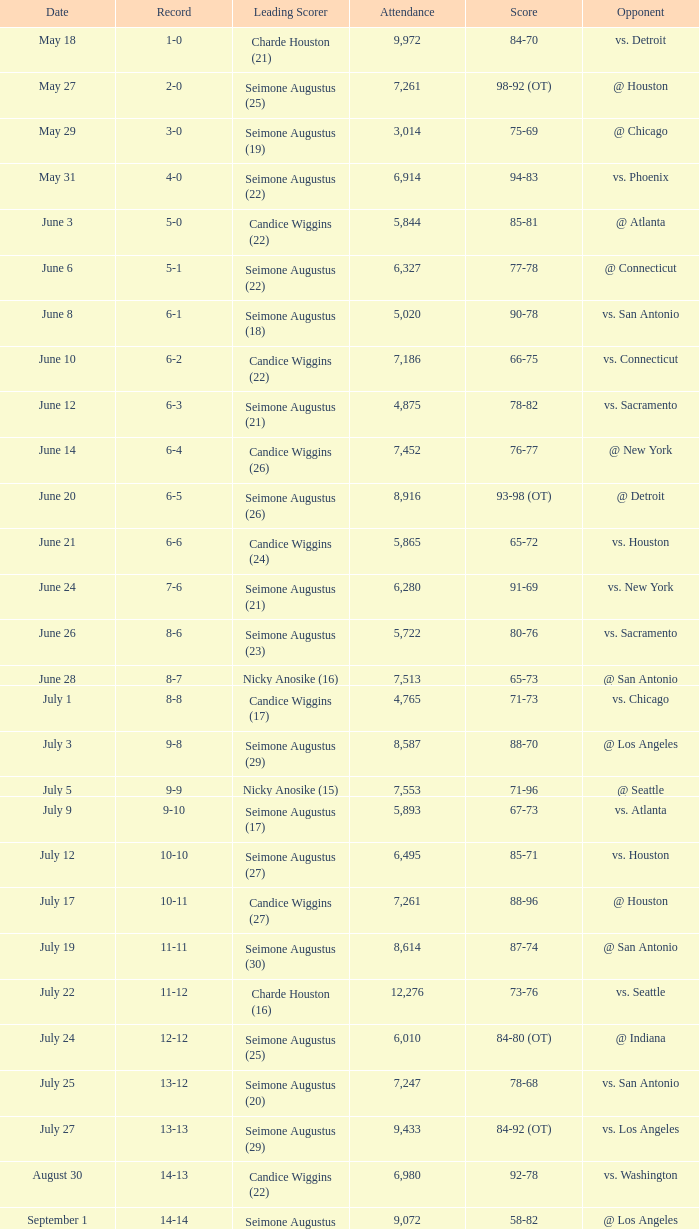Which Attendance has a Date of september 7? 7999.0. 